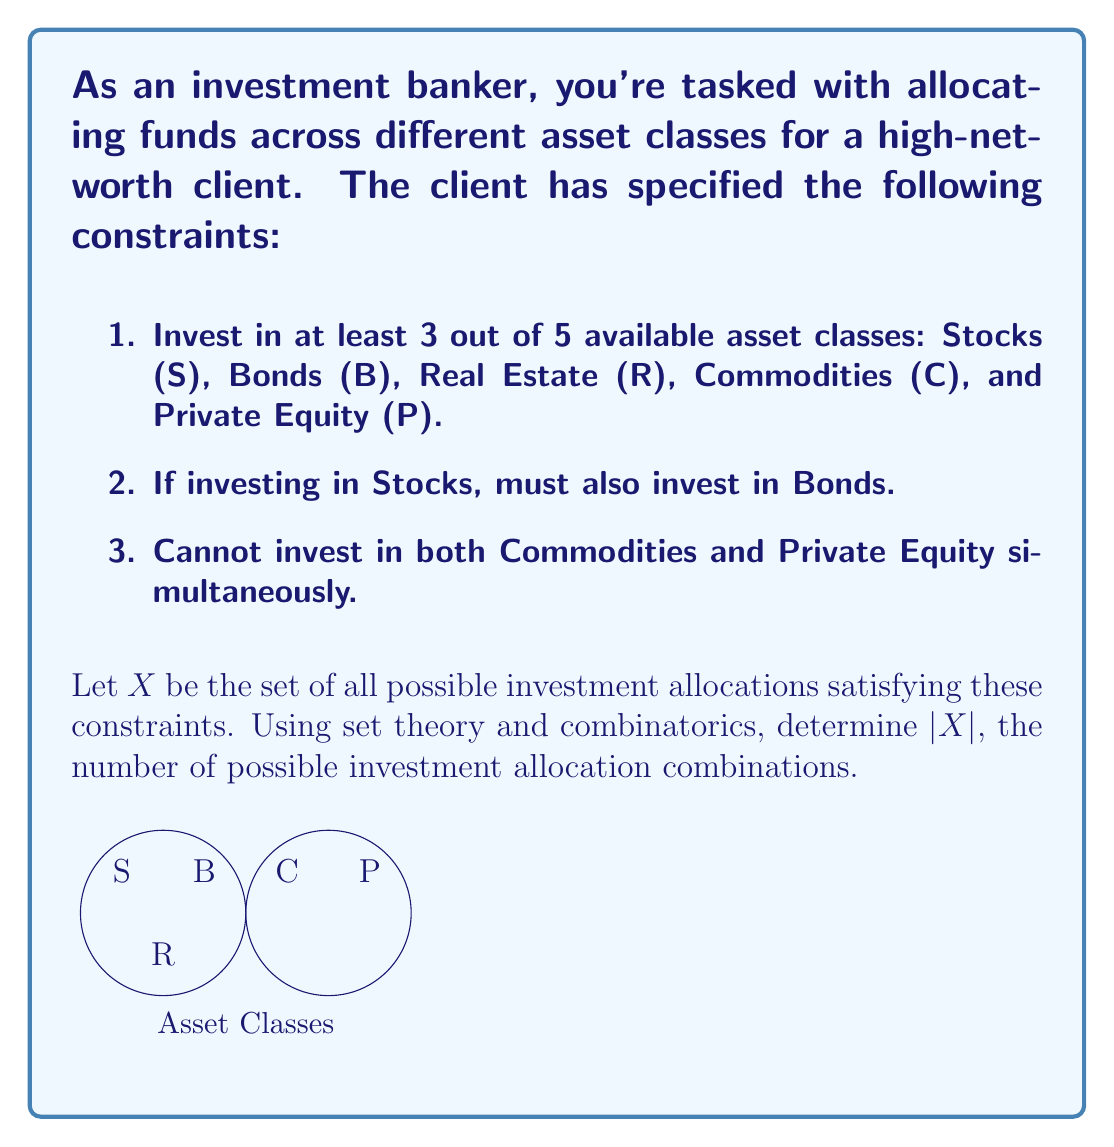Can you answer this question? Let's approach this step-by-step using set theory and combinatorics:

1) First, we need to consider the total number of asset classes: 5.

2) The constraint of investing in at least 3 out of 5 asset classes means we need to consider combinations of 3, 4, and 5 asset classes.

3) Let's break it down by the number of asset classes chosen:

   a) For 5 asset classes: There's only one way to choose all 5, but this violates constraint 3. So this case contributes 0 to $|X|$.

   b) For 4 asset classes: There are $\binom{5}{4} = 5$ ways to choose 4 out of 5. However, we can't choose both C and P (constraint 3), and we must include both S and B if S is chosen (constraint 2). This leaves us with 3 valid combinations: {S,B,R,C}, {S,B,R,P}, and {B,R,C,P}.

   c) For 3 asset classes: There are $\binom{5}{3} = 10$ ways to choose 3 out of 5. However:
      - We must include B if S is included (constraint 2)
      - We can't include both C and P (constraint 3)

      This leaves us with the following valid combinations:
      {S,B,R}, {S,B,C}, {S,B,P}, {B,R,C}, {B,R,P}, {R,C,P}

4) Adding up all valid combinations:
   $|X| = 0 + 3 + 6 = 9$

Therefore, there are 9 possible investment allocation combinations that satisfy all constraints.
Answer: $|X| = 9$ 